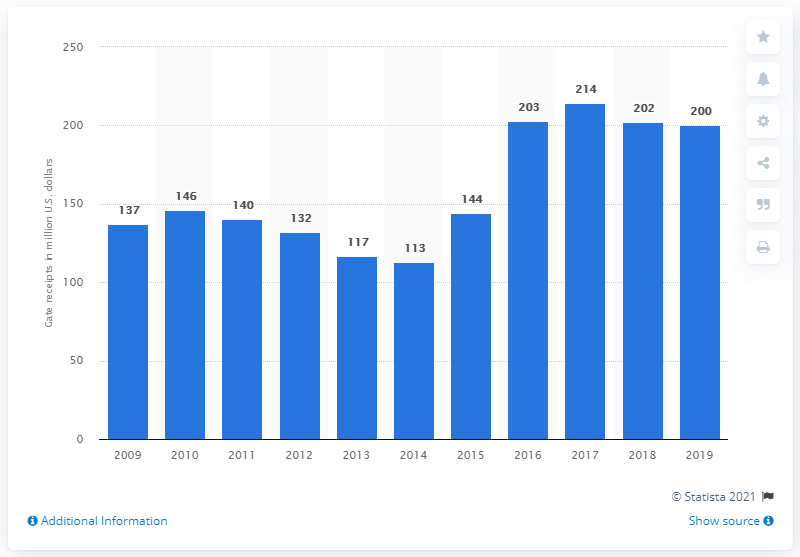Identify some key points in this picture. The gate receipts of the Chicago Cubs in 2019 were 200. 